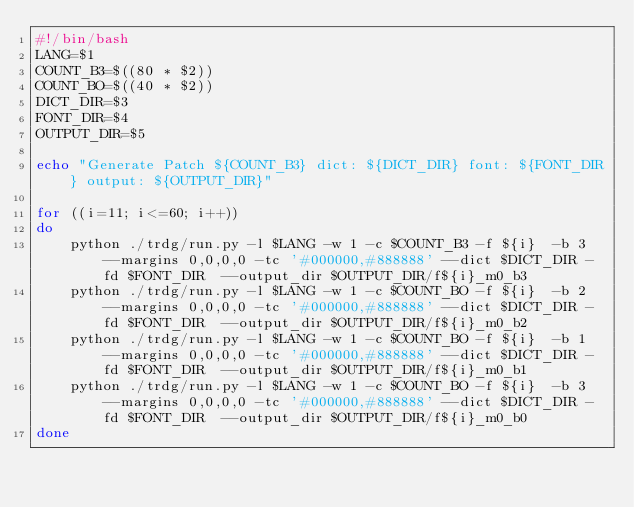<code> <loc_0><loc_0><loc_500><loc_500><_Bash_>#!/bin/bash
LANG=$1
COUNT_B3=$((80 * $2))
COUNT_BO=$((40 * $2))
DICT_DIR=$3
FONT_DIR=$4
OUTPUT_DIR=$5 

echo "Generate Patch ${COUNT_B3} dict: ${DICT_DIR} font: ${FONT_DIR} output: ${OUTPUT_DIR}"

for ((i=11; i<=60; i++))
do 
    python ./trdg/run.py -l $LANG -w 1 -c $COUNT_B3 -f ${i}  -b 3 --margins 0,0,0,0 -tc '#000000,#888888' --dict $DICT_DIR -fd $FONT_DIR  --output_dir $OUTPUT_DIR/f${i}_m0_b3 
    python ./trdg/run.py -l $LANG -w 1 -c $COUNT_BO -f ${i}  -b 2 --margins 0,0,0,0 -tc '#000000,#888888' --dict $DICT_DIR -fd $FONT_DIR  --output_dir $OUTPUT_DIR/f${i}_m0_b2 
    python ./trdg/run.py -l $LANG -w 1 -c $COUNT_BO -f ${i}  -b 1 --margins 0,0,0,0 -tc '#000000,#888888' --dict $DICT_DIR -fd $FONT_DIR  --output_dir $OUTPUT_DIR/f${i}_m0_b1 
    python ./trdg/run.py -l $LANG -w 1 -c $COUNT_BO -f ${i}  -b 3 --margins 0,0,0,0 -tc '#000000,#888888' --dict $DICT_DIR -fd $FONT_DIR  --output_dir $OUTPUT_DIR/f${i}_m0_b0 
done 
</code> 